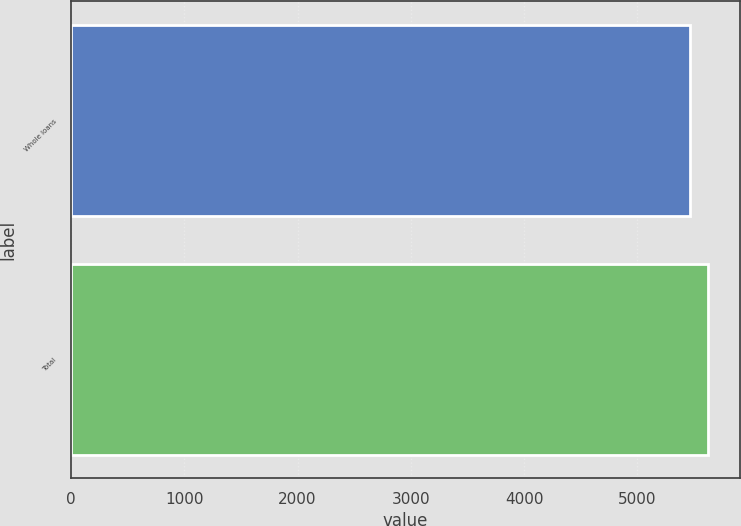Convert chart. <chart><loc_0><loc_0><loc_500><loc_500><bar_chart><fcel>Whole loans<fcel>Total<nl><fcel>5468<fcel>5624<nl></chart> 